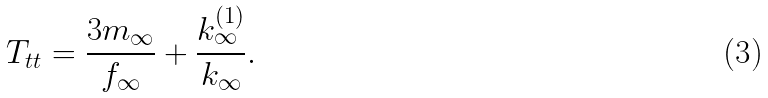<formula> <loc_0><loc_0><loc_500><loc_500>T _ { t t } = \frac { 3 m _ { \infty } } { f _ { \infty } } + \frac { k ^ { ( 1 ) } _ { \infty } } { k _ { \infty } } .</formula> 